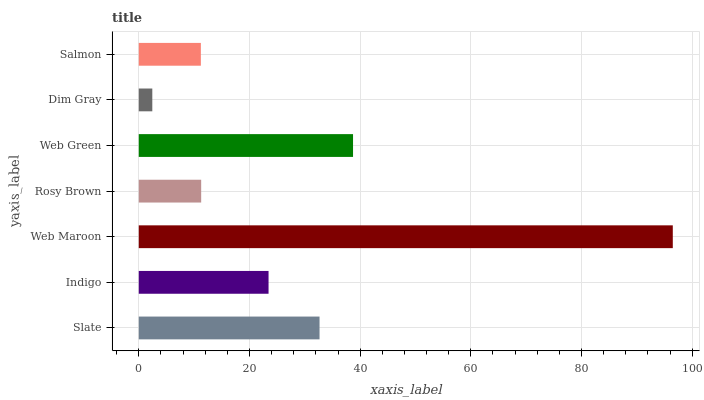Is Dim Gray the minimum?
Answer yes or no. Yes. Is Web Maroon the maximum?
Answer yes or no. Yes. Is Indigo the minimum?
Answer yes or no. No. Is Indigo the maximum?
Answer yes or no. No. Is Slate greater than Indigo?
Answer yes or no. Yes. Is Indigo less than Slate?
Answer yes or no. Yes. Is Indigo greater than Slate?
Answer yes or no. No. Is Slate less than Indigo?
Answer yes or no. No. Is Indigo the high median?
Answer yes or no. Yes. Is Indigo the low median?
Answer yes or no. Yes. Is Rosy Brown the high median?
Answer yes or no. No. Is Dim Gray the low median?
Answer yes or no. No. 